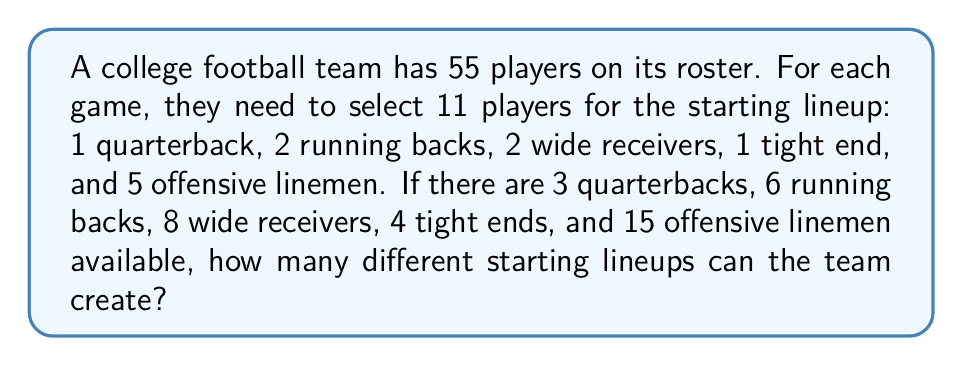Help me with this question. Let's break this down step-by-step:

1) We need to choose:
   - 1 out of 3 quarterbacks
   - 2 out of 6 running backs
   - 2 out of 8 wide receivers
   - 1 out of 4 tight ends
   - 5 out of 15 offensive linemen

2) For each position, we can use the combination formula:
   $C(n,r) = \frac{n!}{r!(n-r)!}$

3) Let's calculate each:
   - Quarterbacks: $C(3,1) = \frac{3!}{1!(3-1)!} = 3$
   - Running backs: $C(6,2) = \frac{6!}{2!(6-2)!} = 15$
   - Wide receivers: $C(8,2) = \frac{8!}{2!(8-2)!} = 28$
   - Tight ends: $C(4,1) = \frac{4!}{1!(4-1)!} = 4$
   - Offensive linemen: $C(15,5) = \frac{15!}{5!(15-5)!} = 3003$

4) According to the multiplication principle, the total number of possible lineups is the product of these individual combinations:

   $$ 3 \times 15 \times 28 \times 4 \times 3003 = 15,135,120 $$

Therefore, the team can create 15,135,120 different starting lineups.
Answer: 15,135,120 